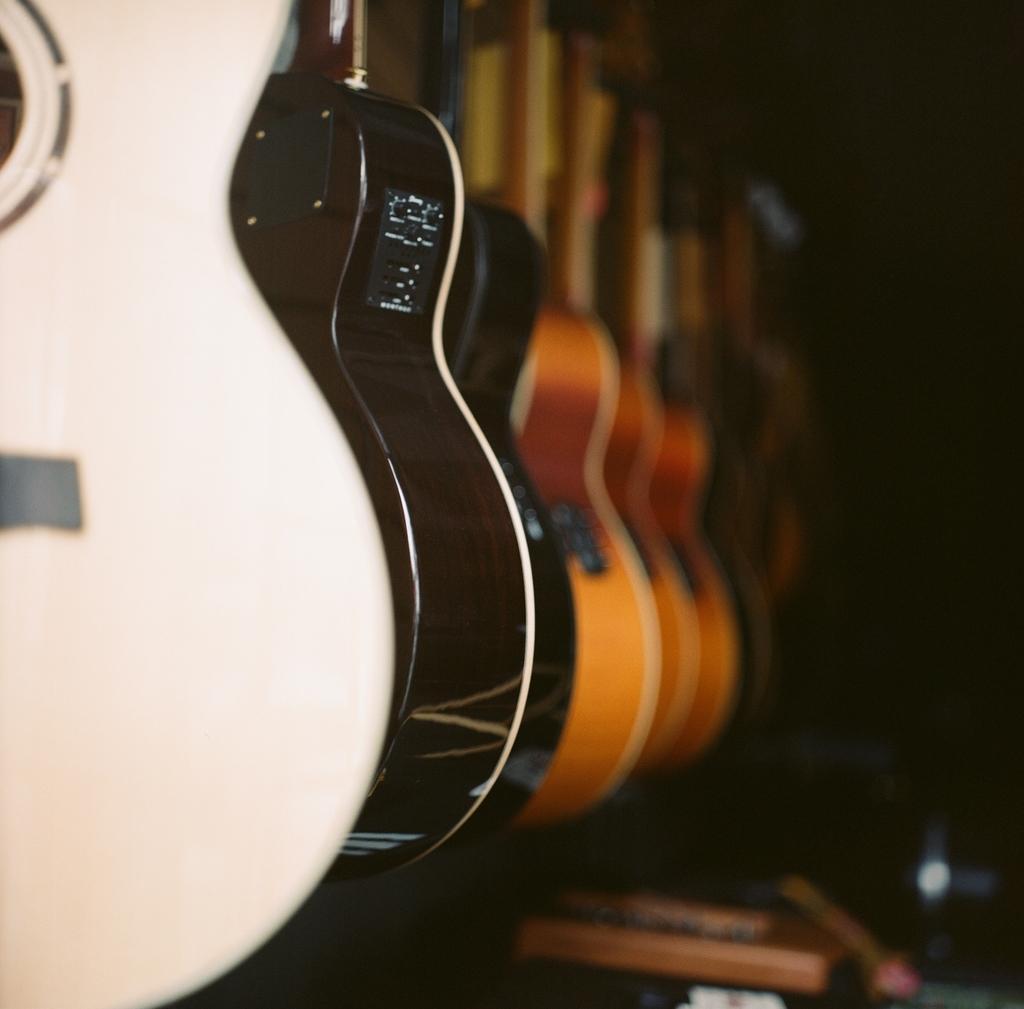In one or two sentences, can you explain what this image depicts? In this picture we can see some guitars, there is a dark background. 